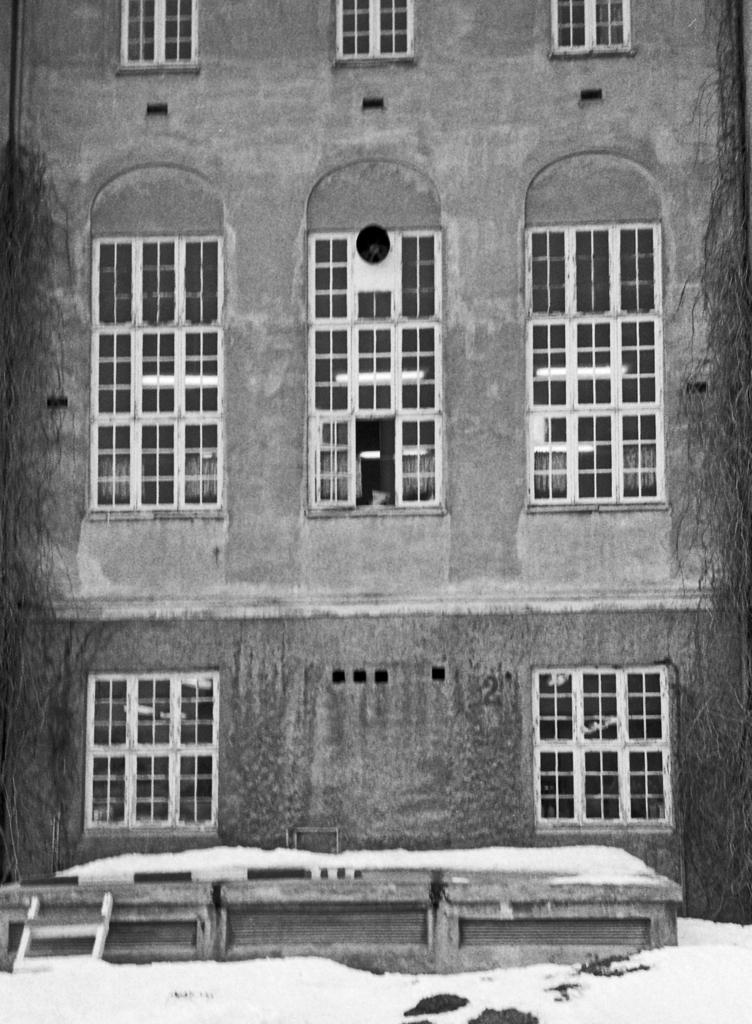What type of image is present in the picture? The image contains a black and white picture. What is the subject of the black and white picture? The picture is of a building. Where is the key located in the image? There is no key present in the image. What type of animal can be seen grazing near the building in the image? There are no animals present in the image; it only features a black and white picture of a building. 